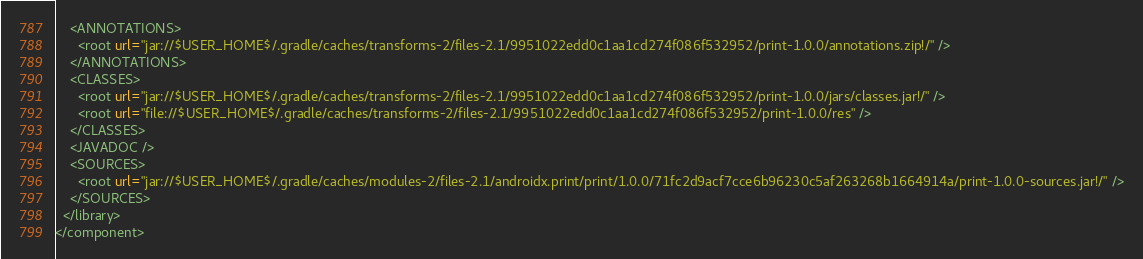Convert code to text. <code><loc_0><loc_0><loc_500><loc_500><_XML_>    <ANNOTATIONS>
      <root url="jar://$USER_HOME$/.gradle/caches/transforms-2/files-2.1/9951022edd0c1aa1cd274f086f532952/print-1.0.0/annotations.zip!/" />
    </ANNOTATIONS>
    <CLASSES>
      <root url="jar://$USER_HOME$/.gradle/caches/transforms-2/files-2.1/9951022edd0c1aa1cd274f086f532952/print-1.0.0/jars/classes.jar!/" />
      <root url="file://$USER_HOME$/.gradle/caches/transforms-2/files-2.1/9951022edd0c1aa1cd274f086f532952/print-1.0.0/res" />
    </CLASSES>
    <JAVADOC />
    <SOURCES>
      <root url="jar://$USER_HOME$/.gradle/caches/modules-2/files-2.1/androidx.print/print/1.0.0/71fc2d9acf7cce6b96230c5af263268b1664914a/print-1.0.0-sources.jar!/" />
    </SOURCES>
  </library>
</component></code> 